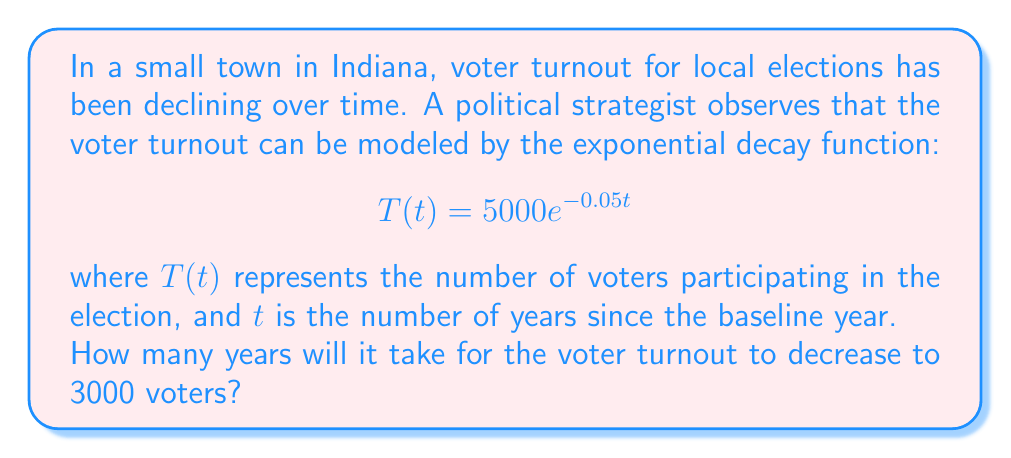Can you answer this question? To solve this problem, we need to use the exponential decay model and solve for $t$ when $T(t) = 3000$. Let's approach this step-by-step:

1) We start with the given equation:
   $$T(t) = 5000e^{-0.05t}$$

2) We want to find $t$ when $T(t) = 3000$, so we substitute this:
   $$3000 = 5000e^{-0.05t}$$

3) Divide both sides by 5000:
   $$\frac{3000}{5000} = e^{-0.05t}$$
   $$0.6 = e^{-0.05t}$$

4) Take the natural logarithm of both sides:
   $$\ln(0.6) = \ln(e^{-0.05t})$$
   $$\ln(0.6) = -0.05t$$

5) Solve for $t$:
   $$t = -\frac{\ln(0.6)}{0.05}$$

6) Calculate the result:
   $$t \approx 10.23$$

7) Since we're dealing with years, we round up to the nearest whole year.
Answer: It will take 11 years for the voter turnout to decrease to 3000 voters. 